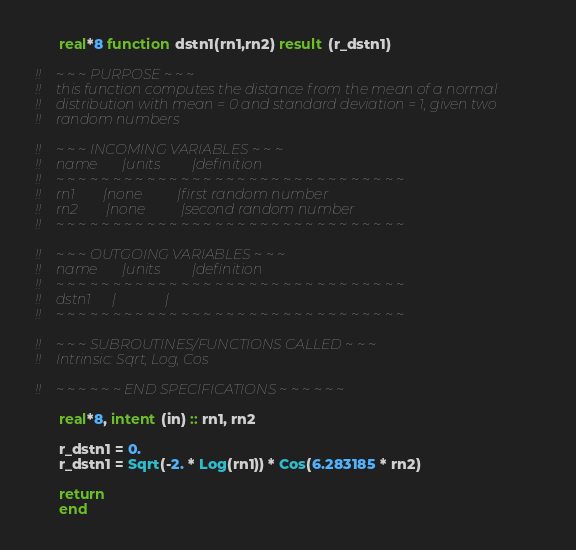Convert code to text. <code><loc_0><loc_0><loc_500><loc_500><_FORTRAN_>      real*8 function dstn1(rn1,rn2) result (r_dstn1)

!!    ~ ~ ~ PURPOSE ~ ~ ~
!!    this function computes the distance from the mean of a normal 
!!    distribution with mean = 0 and standard deviation = 1, given two
!!    random numbers

!!    ~ ~ ~ INCOMING VARIABLES ~ ~ ~
!!    name       |units         |definition
!!    ~ ~ ~ ~ ~ ~ ~ ~ ~ ~ ~ ~ ~ ~ ~ ~ ~ ~ ~ ~ ~ ~ ~ ~ ~ ~ ~ ~ ~ ~ ~ 
!!    rn1        |none          |first random number
!!    rn2        |none          |second random number
!!    ~ ~ ~ ~ ~ ~ ~ ~ ~ ~ ~ ~ ~ ~ ~ ~ ~ ~ ~ ~ ~ ~ ~ ~ ~ ~ ~ ~ ~ ~ ~ 

!!    ~ ~ ~ OUTGOING VARIABLES ~ ~ ~
!!    name       |units         |definition
!!    ~ ~ ~ ~ ~ ~ ~ ~ ~ ~ ~ ~ ~ ~ ~ ~ ~ ~ ~ ~ ~ ~ ~ ~ ~ ~ ~ ~ ~ ~ ~ 
!!    dstn1      |              |
!!    ~ ~ ~ ~ ~ ~ ~ ~ ~ ~ ~ ~ ~ ~ ~ ~ ~ ~ ~ ~ ~ ~ ~ ~ ~ ~ ~ ~ ~ ~ ~ 

!!    ~ ~ ~ SUBROUTINES/FUNCTIONS CALLED ~ ~ ~
!!    Intrinsic: Sqrt, Log, Cos

!!    ~ ~ ~ ~ ~ ~ END SPECIFICATIONS ~ ~ ~ ~ ~ ~

      real*8, intent (in) :: rn1, rn2

      r_dstn1 = 0.
      r_dstn1 = Sqrt(-2. * Log(rn1)) * Cos(6.283185 * rn2)

      return
      end</code> 